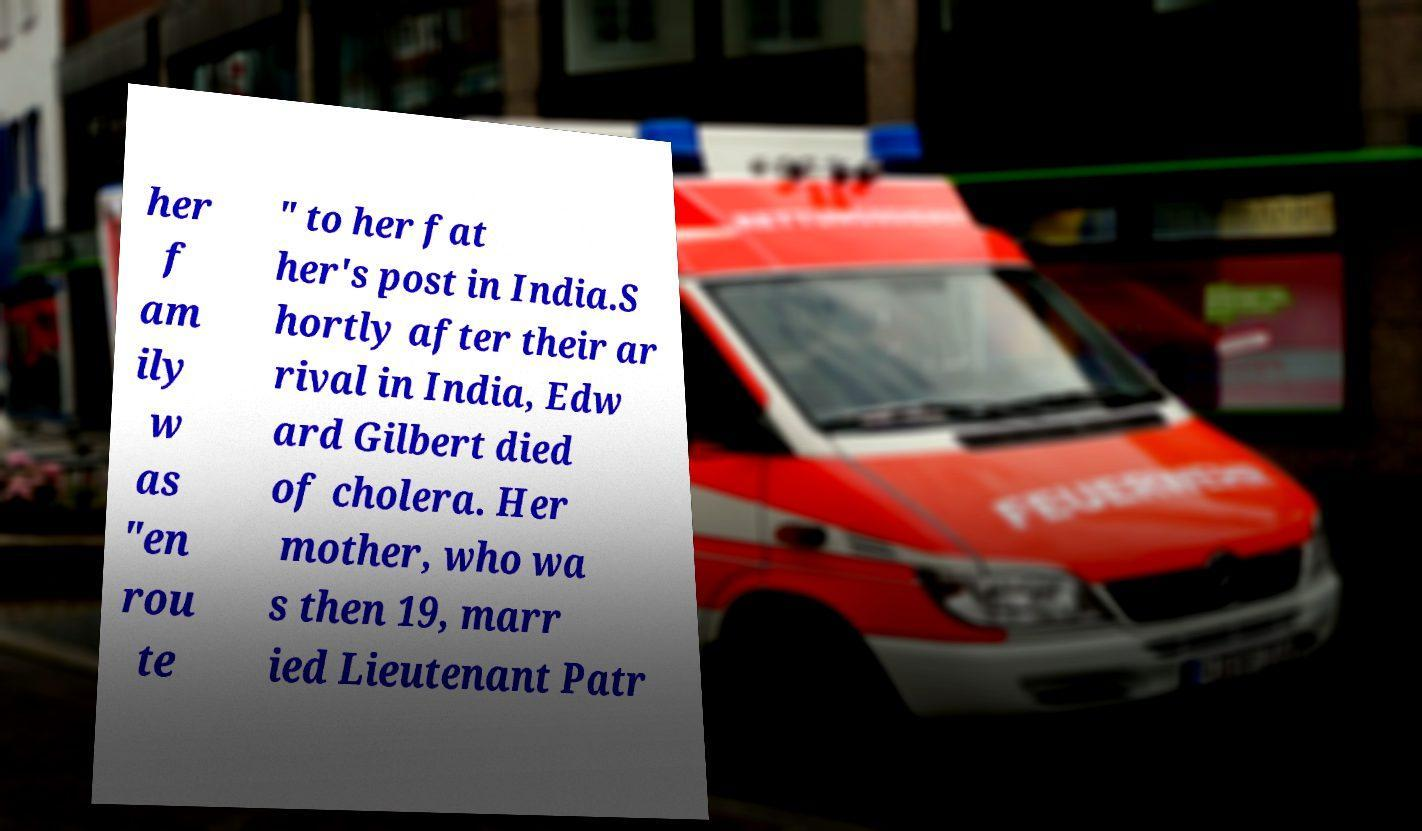Can you accurately transcribe the text from the provided image for me? her f am ily w as "en rou te " to her fat her's post in India.S hortly after their ar rival in India, Edw ard Gilbert died of cholera. Her mother, who wa s then 19, marr ied Lieutenant Patr 